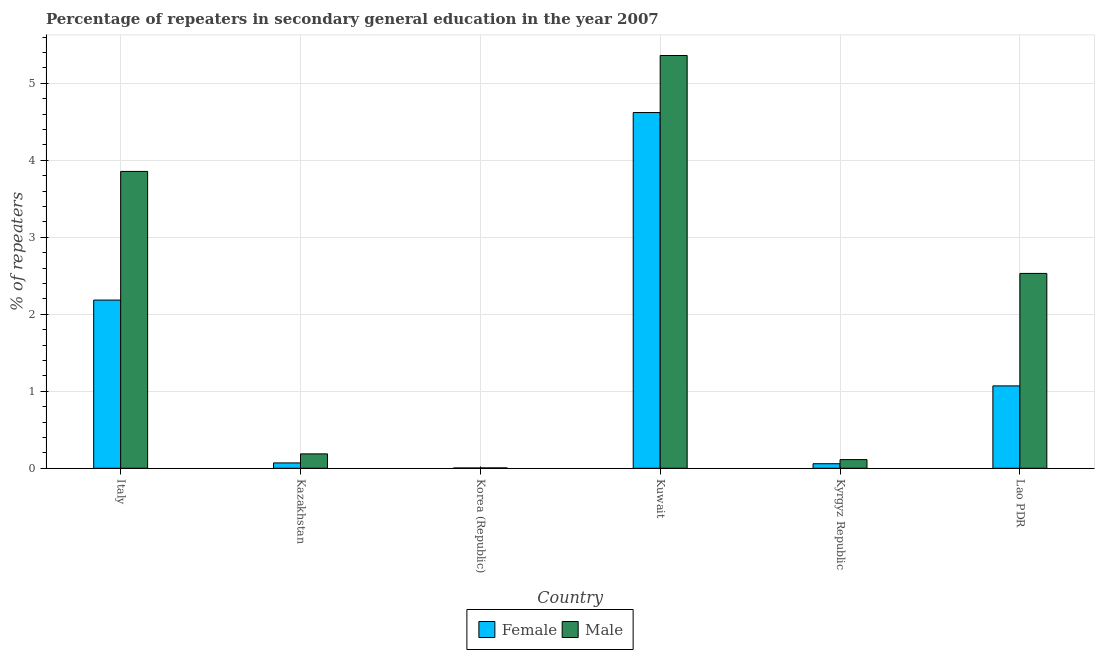How many bars are there on the 4th tick from the left?
Offer a terse response. 2. How many bars are there on the 6th tick from the right?
Keep it short and to the point. 2. What is the label of the 6th group of bars from the left?
Your answer should be very brief. Lao PDR. What is the percentage of male repeaters in Kazakhstan?
Ensure brevity in your answer.  0.19. Across all countries, what is the maximum percentage of male repeaters?
Make the answer very short. 5.36. Across all countries, what is the minimum percentage of male repeaters?
Ensure brevity in your answer.  0. In which country was the percentage of female repeaters maximum?
Provide a succinct answer. Kuwait. In which country was the percentage of male repeaters minimum?
Provide a succinct answer. Korea (Republic). What is the total percentage of male repeaters in the graph?
Provide a short and direct response. 12.05. What is the difference between the percentage of male repeaters in Kazakhstan and that in Lao PDR?
Provide a short and direct response. -2.34. What is the difference between the percentage of female repeaters in Lao PDR and the percentage of male repeaters in Korea (Republic)?
Your answer should be very brief. 1.07. What is the average percentage of female repeaters per country?
Give a very brief answer. 1.33. What is the difference between the percentage of male repeaters and percentage of female repeaters in Lao PDR?
Provide a short and direct response. 1.46. What is the ratio of the percentage of male repeaters in Italy to that in Lao PDR?
Offer a terse response. 1.52. Is the percentage of male repeaters in Korea (Republic) less than that in Lao PDR?
Your response must be concise. Yes. Is the difference between the percentage of female repeaters in Kazakhstan and Lao PDR greater than the difference between the percentage of male repeaters in Kazakhstan and Lao PDR?
Give a very brief answer. Yes. What is the difference between the highest and the second highest percentage of male repeaters?
Your answer should be compact. 1.51. What is the difference between the highest and the lowest percentage of female repeaters?
Offer a terse response. 4.62. In how many countries, is the percentage of female repeaters greater than the average percentage of female repeaters taken over all countries?
Keep it short and to the point. 2. What does the 1st bar from the right in Kazakhstan represents?
Ensure brevity in your answer.  Male. What is the difference between two consecutive major ticks on the Y-axis?
Offer a very short reply. 1. Does the graph contain grids?
Provide a short and direct response. Yes. Where does the legend appear in the graph?
Offer a terse response. Bottom center. How are the legend labels stacked?
Offer a terse response. Horizontal. What is the title of the graph?
Your answer should be very brief. Percentage of repeaters in secondary general education in the year 2007. What is the label or title of the X-axis?
Your response must be concise. Country. What is the label or title of the Y-axis?
Make the answer very short. % of repeaters. What is the % of repeaters in Female in Italy?
Give a very brief answer. 2.18. What is the % of repeaters of Male in Italy?
Provide a succinct answer. 3.86. What is the % of repeaters in Female in Kazakhstan?
Provide a succinct answer. 0.07. What is the % of repeaters of Male in Kazakhstan?
Make the answer very short. 0.19. What is the % of repeaters of Female in Korea (Republic)?
Make the answer very short. 0. What is the % of repeaters in Male in Korea (Republic)?
Make the answer very short. 0. What is the % of repeaters in Female in Kuwait?
Your answer should be very brief. 4.62. What is the % of repeaters in Male in Kuwait?
Keep it short and to the point. 5.36. What is the % of repeaters in Female in Kyrgyz Republic?
Give a very brief answer. 0.06. What is the % of repeaters in Male in Kyrgyz Republic?
Make the answer very short. 0.11. What is the % of repeaters of Female in Lao PDR?
Offer a very short reply. 1.07. What is the % of repeaters of Male in Lao PDR?
Offer a terse response. 2.53. Across all countries, what is the maximum % of repeaters in Female?
Offer a terse response. 4.62. Across all countries, what is the maximum % of repeaters in Male?
Make the answer very short. 5.36. Across all countries, what is the minimum % of repeaters of Female?
Your answer should be compact. 0. Across all countries, what is the minimum % of repeaters of Male?
Keep it short and to the point. 0. What is the total % of repeaters of Female in the graph?
Ensure brevity in your answer.  8.01. What is the total % of repeaters in Male in the graph?
Your answer should be compact. 12.05. What is the difference between the % of repeaters of Female in Italy and that in Kazakhstan?
Your answer should be compact. 2.11. What is the difference between the % of repeaters of Male in Italy and that in Kazakhstan?
Ensure brevity in your answer.  3.67. What is the difference between the % of repeaters in Female in Italy and that in Korea (Republic)?
Your response must be concise. 2.18. What is the difference between the % of repeaters of Male in Italy and that in Korea (Republic)?
Your answer should be compact. 3.85. What is the difference between the % of repeaters in Female in Italy and that in Kuwait?
Provide a succinct answer. -2.44. What is the difference between the % of repeaters in Male in Italy and that in Kuwait?
Keep it short and to the point. -1.51. What is the difference between the % of repeaters in Female in Italy and that in Kyrgyz Republic?
Give a very brief answer. 2.13. What is the difference between the % of repeaters of Male in Italy and that in Kyrgyz Republic?
Your answer should be compact. 3.74. What is the difference between the % of repeaters of Female in Italy and that in Lao PDR?
Ensure brevity in your answer.  1.11. What is the difference between the % of repeaters in Male in Italy and that in Lao PDR?
Keep it short and to the point. 1.32. What is the difference between the % of repeaters in Female in Kazakhstan and that in Korea (Republic)?
Ensure brevity in your answer.  0.07. What is the difference between the % of repeaters in Male in Kazakhstan and that in Korea (Republic)?
Provide a succinct answer. 0.18. What is the difference between the % of repeaters in Female in Kazakhstan and that in Kuwait?
Your answer should be very brief. -4.55. What is the difference between the % of repeaters of Male in Kazakhstan and that in Kuwait?
Keep it short and to the point. -5.17. What is the difference between the % of repeaters in Female in Kazakhstan and that in Kyrgyz Republic?
Your answer should be compact. 0.01. What is the difference between the % of repeaters in Male in Kazakhstan and that in Kyrgyz Republic?
Keep it short and to the point. 0.07. What is the difference between the % of repeaters in Female in Kazakhstan and that in Lao PDR?
Keep it short and to the point. -1. What is the difference between the % of repeaters in Male in Kazakhstan and that in Lao PDR?
Your answer should be very brief. -2.34. What is the difference between the % of repeaters in Female in Korea (Republic) and that in Kuwait?
Ensure brevity in your answer.  -4.62. What is the difference between the % of repeaters in Male in Korea (Republic) and that in Kuwait?
Ensure brevity in your answer.  -5.36. What is the difference between the % of repeaters of Female in Korea (Republic) and that in Kyrgyz Republic?
Make the answer very short. -0.06. What is the difference between the % of repeaters in Male in Korea (Republic) and that in Kyrgyz Republic?
Your answer should be very brief. -0.11. What is the difference between the % of repeaters in Female in Korea (Republic) and that in Lao PDR?
Your answer should be very brief. -1.07. What is the difference between the % of repeaters of Male in Korea (Republic) and that in Lao PDR?
Provide a succinct answer. -2.53. What is the difference between the % of repeaters of Female in Kuwait and that in Kyrgyz Republic?
Ensure brevity in your answer.  4.56. What is the difference between the % of repeaters in Male in Kuwait and that in Kyrgyz Republic?
Keep it short and to the point. 5.25. What is the difference between the % of repeaters of Female in Kuwait and that in Lao PDR?
Provide a short and direct response. 3.55. What is the difference between the % of repeaters in Male in Kuwait and that in Lao PDR?
Provide a short and direct response. 2.83. What is the difference between the % of repeaters in Female in Kyrgyz Republic and that in Lao PDR?
Give a very brief answer. -1.01. What is the difference between the % of repeaters in Male in Kyrgyz Republic and that in Lao PDR?
Provide a succinct answer. -2.42. What is the difference between the % of repeaters of Female in Italy and the % of repeaters of Male in Kazakhstan?
Ensure brevity in your answer.  2. What is the difference between the % of repeaters in Female in Italy and the % of repeaters in Male in Korea (Republic)?
Your response must be concise. 2.18. What is the difference between the % of repeaters in Female in Italy and the % of repeaters in Male in Kuwait?
Offer a very short reply. -3.18. What is the difference between the % of repeaters in Female in Italy and the % of repeaters in Male in Kyrgyz Republic?
Offer a very short reply. 2.07. What is the difference between the % of repeaters of Female in Italy and the % of repeaters of Male in Lao PDR?
Give a very brief answer. -0.35. What is the difference between the % of repeaters of Female in Kazakhstan and the % of repeaters of Male in Korea (Republic)?
Make the answer very short. 0.06. What is the difference between the % of repeaters of Female in Kazakhstan and the % of repeaters of Male in Kuwait?
Give a very brief answer. -5.29. What is the difference between the % of repeaters of Female in Kazakhstan and the % of repeaters of Male in Kyrgyz Republic?
Provide a short and direct response. -0.04. What is the difference between the % of repeaters in Female in Kazakhstan and the % of repeaters in Male in Lao PDR?
Offer a terse response. -2.46. What is the difference between the % of repeaters of Female in Korea (Republic) and the % of repeaters of Male in Kuwait?
Give a very brief answer. -5.36. What is the difference between the % of repeaters of Female in Korea (Republic) and the % of repeaters of Male in Kyrgyz Republic?
Your answer should be very brief. -0.11. What is the difference between the % of repeaters in Female in Korea (Republic) and the % of repeaters in Male in Lao PDR?
Provide a succinct answer. -2.53. What is the difference between the % of repeaters in Female in Kuwait and the % of repeaters in Male in Kyrgyz Republic?
Provide a succinct answer. 4.51. What is the difference between the % of repeaters in Female in Kuwait and the % of repeaters in Male in Lao PDR?
Ensure brevity in your answer.  2.09. What is the difference between the % of repeaters in Female in Kyrgyz Republic and the % of repeaters in Male in Lao PDR?
Keep it short and to the point. -2.47. What is the average % of repeaters in Female per country?
Your answer should be compact. 1.33. What is the average % of repeaters of Male per country?
Give a very brief answer. 2.01. What is the difference between the % of repeaters of Female and % of repeaters of Male in Italy?
Your answer should be very brief. -1.67. What is the difference between the % of repeaters in Female and % of repeaters in Male in Kazakhstan?
Ensure brevity in your answer.  -0.12. What is the difference between the % of repeaters in Female and % of repeaters in Male in Korea (Republic)?
Keep it short and to the point. -0. What is the difference between the % of repeaters in Female and % of repeaters in Male in Kuwait?
Provide a succinct answer. -0.74. What is the difference between the % of repeaters of Female and % of repeaters of Male in Kyrgyz Republic?
Your answer should be very brief. -0.05. What is the difference between the % of repeaters in Female and % of repeaters in Male in Lao PDR?
Your answer should be very brief. -1.46. What is the ratio of the % of repeaters in Female in Italy to that in Kazakhstan?
Your answer should be compact. 31.42. What is the ratio of the % of repeaters of Male in Italy to that in Kazakhstan?
Your answer should be compact. 20.63. What is the ratio of the % of repeaters of Female in Italy to that in Korea (Republic)?
Your response must be concise. 585.64. What is the ratio of the % of repeaters of Male in Italy to that in Korea (Republic)?
Provide a succinct answer. 804.91. What is the ratio of the % of repeaters of Female in Italy to that in Kuwait?
Your response must be concise. 0.47. What is the ratio of the % of repeaters of Male in Italy to that in Kuwait?
Provide a short and direct response. 0.72. What is the ratio of the % of repeaters in Female in Italy to that in Kyrgyz Republic?
Provide a short and direct response. 36.96. What is the ratio of the % of repeaters in Male in Italy to that in Kyrgyz Republic?
Ensure brevity in your answer.  34.22. What is the ratio of the % of repeaters of Female in Italy to that in Lao PDR?
Make the answer very short. 2.04. What is the ratio of the % of repeaters of Male in Italy to that in Lao PDR?
Offer a terse response. 1.52. What is the ratio of the % of repeaters in Female in Kazakhstan to that in Korea (Republic)?
Offer a terse response. 18.64. What is the ratio of the % of repeaters of Male in Kazakhstan to that in Korea (Republic)?
Your answer should be compact. 39.02. What is the ratio of the % of repeaters in Female in Kazakhstan to that in Kuwait?
Offer a very short reply. 0.01. What is the ratio of the % of repeaters of Male in Kazakhstan to that in Kuwait?
Make the answer very short. 0.03. What is the ratio of the % of repeaters in Female in Kazakhstan to that in Kyrgyz Republic?
Offer a terse response. 1.18. What is the ratio of the % of repeaters in Male in Kazakhstan to that in Kyrgyz Republic?
Offer a very short reply. 1.66. What is the ratio of the % of repeaters of Female in Kazakhstan to that in Lao PDR?
Your response must be concise. 0.07. What is the ratio of the % of repeaters in Male in Kazakhstan to that in Lao PDR?
Offer a terse response. 0.07. What is the ratio of the % of repeaters in Female in Korea (Republic) to that in Kuwait?
Your answer should be very brief. 0. What is the ratio of the % of repeaters in Male in Korea (Republic) to that in Kuwait?
Make the answer very short. 0. What is the ratio of the % of repeaters in Female in Korea (Republic) to that in Kyrgyz Republic?
Your response must be concise. 0.06. What is the ratio of the % of repeaters in Male in Korea (Republic) to that in Kyrgyz Republic?
Give a very brief answer. 0.04. What is the ratio of the % of repeaters of Female in Korea (Republic) to that in Lao PDR?
Offer a terse response. 0. What is the ratio of the % of repeaters of Male in Korea (Republic) to that in Lao PDR?
Keep it short and to the point. 0. What is the ratio of the % of repeaters in Female in Kuwait to that in Kyrgyz Republic?
Your answer should be compact. 78.18. What is the ratio of the % of repeaters of Male in Kuwait to that in Kyrgyz Republic?
Your response must be concise. 47.58. What is the ratio of the % of repeaters of Female in Kuwait to that in Lao PDR?
Ensure brevity in your answer.  4.32. What is the ratio of the % of repeaters of Male in Kuwait to that in Lao PDR?
Give a very brief answer. 2.12. What is the ratio of the % of repeaters in Female in Kyrgyz Republic to that in Lao PDR?
Offer a terse response. 0.06. What is the ratio of the % of repeaters in Male in Kyrgyz Republic to that in Lao PDR?
Offer a terse response. 0.04. What is the difference between the highest and the second highest % of repeaters of Female?
Your answer should be compact. 2.44. What is the difference between the highest and the second highest % of repeaters in Male?
Provide a short and direct response. 1.51. What is the difference between the highest and the lowest % of repeaters of Female?
Offer a terse response. 4.62. What is the difference between the highest and the lowest % of repeaters in Male?
Provide a short and direct response. 5.36. 